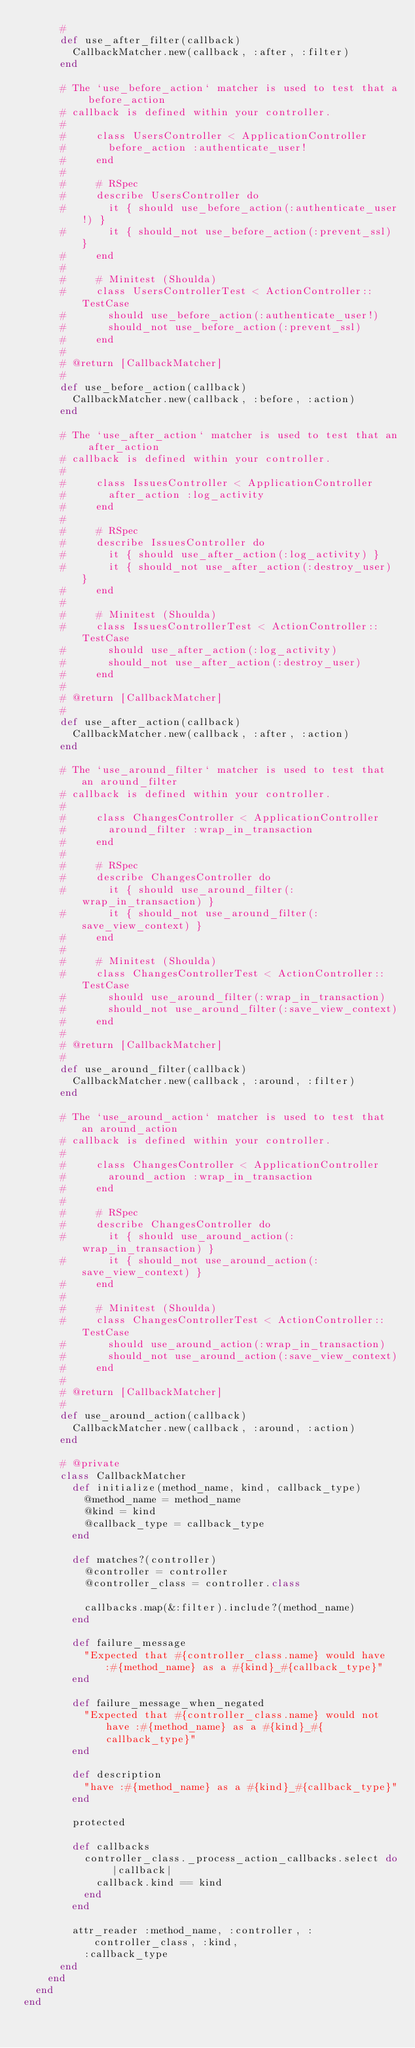Convert code to text. <code><loc_0><loc_0><loc_500><loc_500><_Ruby_>      #
      def use_after_filter(callback)
        CallbackMatcher.new(callback, :after, :filter)
      end

      # The `use_before_action` matcher is used to test that a before_action
      # callback is defined within your controller.
      #
      #     class UsersController < ApplicationController
      #       before_action :authenticate_user!
      #     end
      #
      #     # RSpec
      #     describe UsersController do
      #       it { should use_before_action(:authenticate_user!) }
      #       it { should_not use_before_action(:prevent_ssl) }
      #     end
      #
      #     # Minitest (Shoulda)
      #     class UsersControllerTest < ActionController::TestCase
      #       should use_before_action(:authenticate_user!)
      #       should_not use_before_action(:prevent_ssl)
      #     end
      #
      # @return [CallbackMatcher]
      #
      def use_before_action(callback)
        CallbackMatcher.new(callback, :before, :action)
      end

      # The `use_after_action` matcher is used to test that an after_action
      # callback is defined within your controller.
      #
      #     class IssuesController < ApplicationController
      #       after_action :log_activity
      #     end
      #
      #     # RSpec
      #     describe IssuesController do
      #       it { should use_after_action(:log_activity) }
      #       it { should_not use_after_action(:destroy_user) }
      #     end
      #
      #     # Minitest (Shoulda)
      #     class IssuesControllerTest < ActionController::TestCase
      #       should use_after_action(:log_activity)
      #       should_not use_after_action(:destroy_user)
      #     end
      #
      # @return [CallbackMatcher]
      #
      def use_after_action(callback)
        CallbackMatcher.new(callback, :after, :action)
      end

      # The `use_around_filter` matcher is used to test that an around_filter
      # callback is defined within your controller.
      #
      #     class ChangesController < ApplicationController
      #       around_filter :wrap_in_transaction
      #     end
      #
      #     # RSpec
      #     describe ChangesController do
      #       it { should use_around_filter(:wrap_in_transaction) }
      #       it { should_not use_around_filter(:save_view_context) }
      #     end
      #
      #     # Minitest (Shoulda)
      #     class ChangesControllerTest < ActionController::TestCase
      #       should use_around_filter(:wrap_in_transaction)
      #       should_not use_around_filter(:save_view_context)
      #     end
      #
      # @return [CallbackMatcher]
      #
      def use_around_filter(callback)
        CallbackMatcher.new(callback, :around, :filter)
      end

      # The `use_around_action` matcher is used to test that an around_action
      # callback is defined within your controller.
      #
      #     class ChangesController < ApplicationController
      #       around_action :wrap_in_transaction
      #     end
      #
      #     # RSpec
      #     describe ChangesController do
      #       it { should use_around_action(:wrap_in_transaction) }
      #       it { should_not use_around_action(:save_view_context) }
      #     end
      #
      #     # Minitest (Shoulda)
      #     class ChangesControllerTest < ActionController::TestCase
      #       should use_around_action(:wrap_in_transaction)
      #       should_not use_around_action(:save_view_context)
      #     end
      #
      # @return [CallbackMatcher]
      #
      def use_around_action(callback)
        CallbackMatcher.new(callback, :around, :action)
      end

      # @private
      class CallbackMatcher
        def initialize(method_name, kind, callback_type)
          @method_name = method_name
          @kind = kind
          @callback_type = callback_type
        end

        def matches?(controller)
          @controller = controller
          @controller_class = controller.class

          callbacks.map(&:filter).include?(method_name)
        end

        def failure_message
          "Expected that #{controller_class.name} would have :#{method_name} as a #{kind}_#{callback_type}"
        end

        def failure_message_when_negated
          "Expected that #{controller_class.name} would not have :#{method_name} as a #{kind}_#{callback_type}"
        end

        def description
          "have :#{method_name} as a #{kind}_#{callback_type}"
        end

        protected

        def callbacks
          controller_class._process_action_callbacks.select do |callback|
            callback.kind == kind
          end
        end

        attr_reader :method_name, :controller, :controller_class, :kind,
          :callback_type
      end
    end
  end
end
</code> 